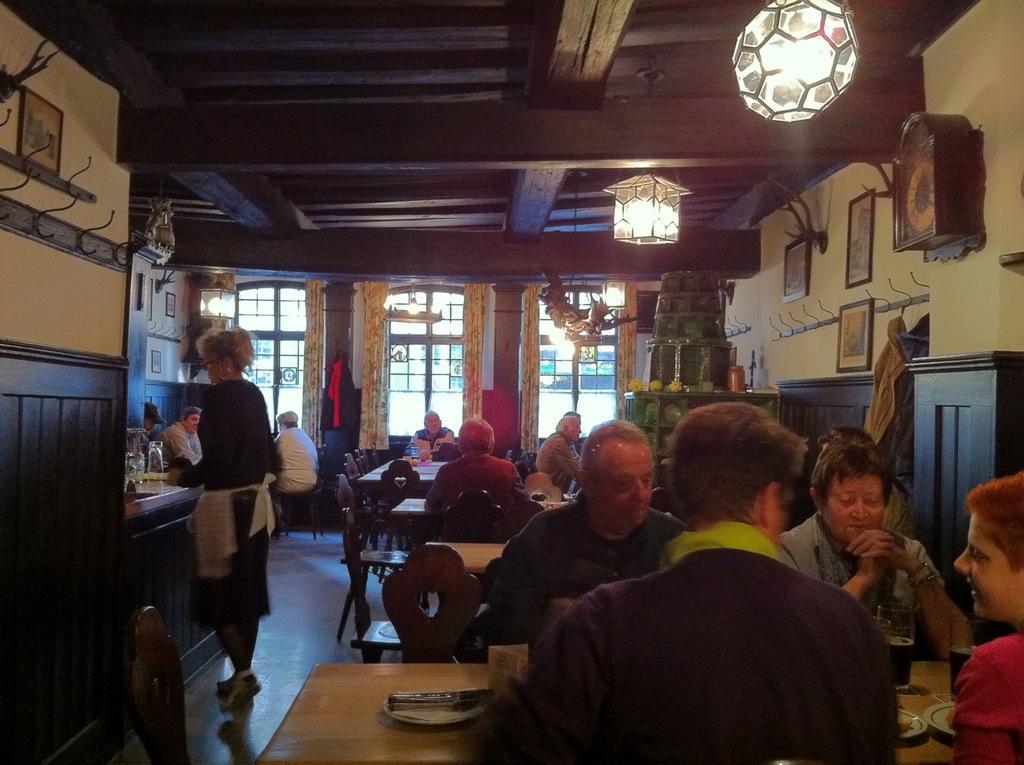Could you give a brief overview of what you see in this image? In this image we can see some group of persons sitting on chairs around tables on which there are some food items, drinks and we can see some paintings attached to the wall, there are some windows, top of the image there is a roof and there are some lights. 